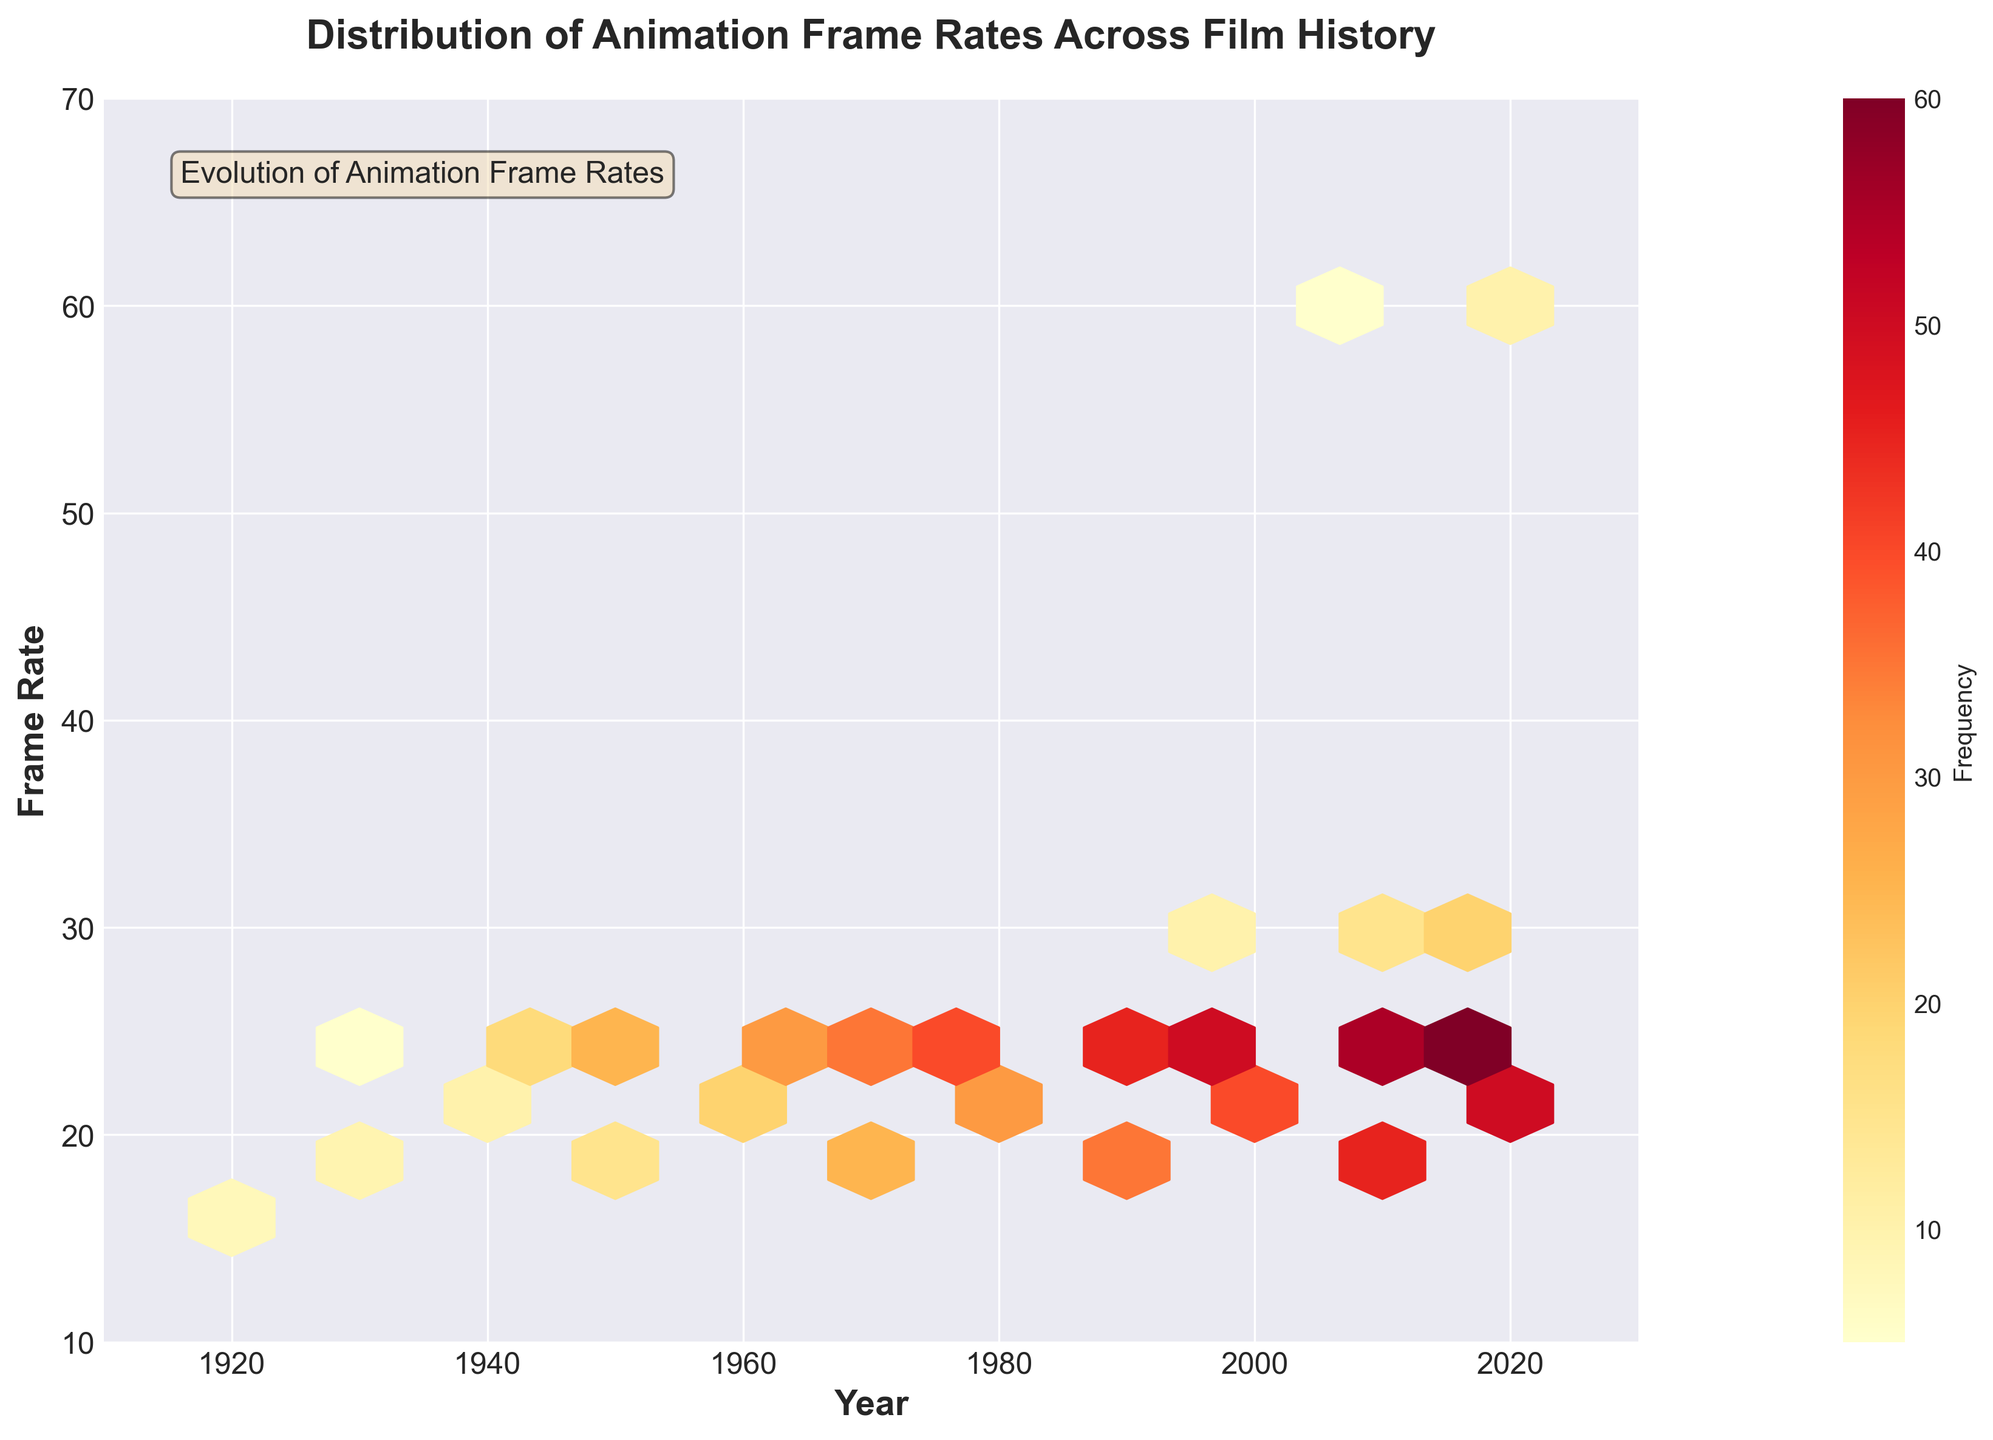What's the title of the figure? The title of the figure is prominently displayed at the top and can be directly read from the plot.
Answer: Distribution of Animation Frame Rates Across Film History What does the color represent in the hexbin plot? The color in the hexbin plot represents the frequency of the frame rates in different years. Darker colors indicate higher frequencies.
Answer: Frequency Which decade has the highest frequency for a frame rate of 24 frames per second? By examining the plot, look for the darkest hexagons along the 24 frames per second line and see which decade they fall in.
Answer: 2020s How many different frame rates are represented in the 1930s? Observing the y-axis for the 1930s, we see hexagons at several positions that represent different frame rates.
Answer: 4 Which frame rate showed an increase in frequency starting from the 2000s? Analyzing the plot from left to right, trace the increase in darkness (frequency) of hexagons starting in the 2000s for different frame rates, particularly focusing on 20, 24, and 30 as they have notable changes.
Answer: 30 What is the range of years displayed on the x-axis? By looking at the limits of the x-axis, the starting and ending years can be read directly.
Answer: 1910 to 2030 Did any frame rate reach a frequency of 60 by 2020? Identify the hexagons around the 2020 mark and check if any of them represent a frequency of 60.
Answer: Yes Which frame rate has the most consistent frequency over the years? Observing the vertical consistency of hexagons in color from left to right helps identify which frame rate maintains a similar frequency over time.
Answer: 24 In which decade did a variety of frame rates first become common? Look for the first decade where multiple hexagons appear along the y-axis, indicating the advent of a variety of frame rates.
Answer: 1930s How does the frequency of the frame rate of 60 fps (frames per second) change from 2010 to 2020? Compare the color intensity of hexagons representing 60 fps between the years 2010 and 2020 to understand the change in frequency.
Answer: Increases 